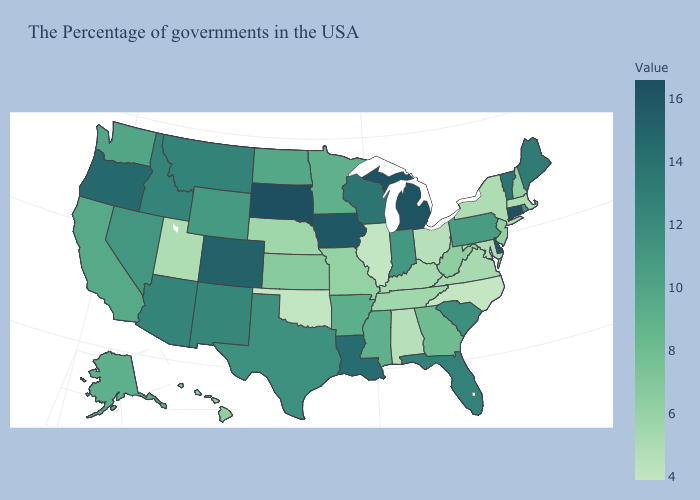Does Nebraska have a higher value than Oklahoma?
Answer briefly. Yes. Does South Dakota have the highest value in the MidWest?
Short answer required. Yes. Is the legend a continuous bar?
Quick response, please. Yes. Among the states that border Pennsylvania , which have the lowest value?
Concise answer only. Ohio. 